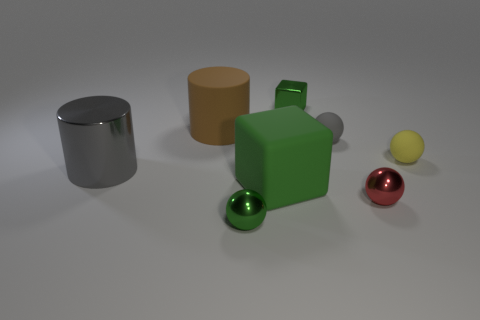What materials do the objects closest to the foreground appear to be made of? The two objects in the foreground appear to be made of different materials. The green one on the left has a matte finish suggestive of a solid, opaque material like plastic or painted wood, while the sphere on the right has a shiny, reflective surface that could imply it's made of metal or polished stone. 